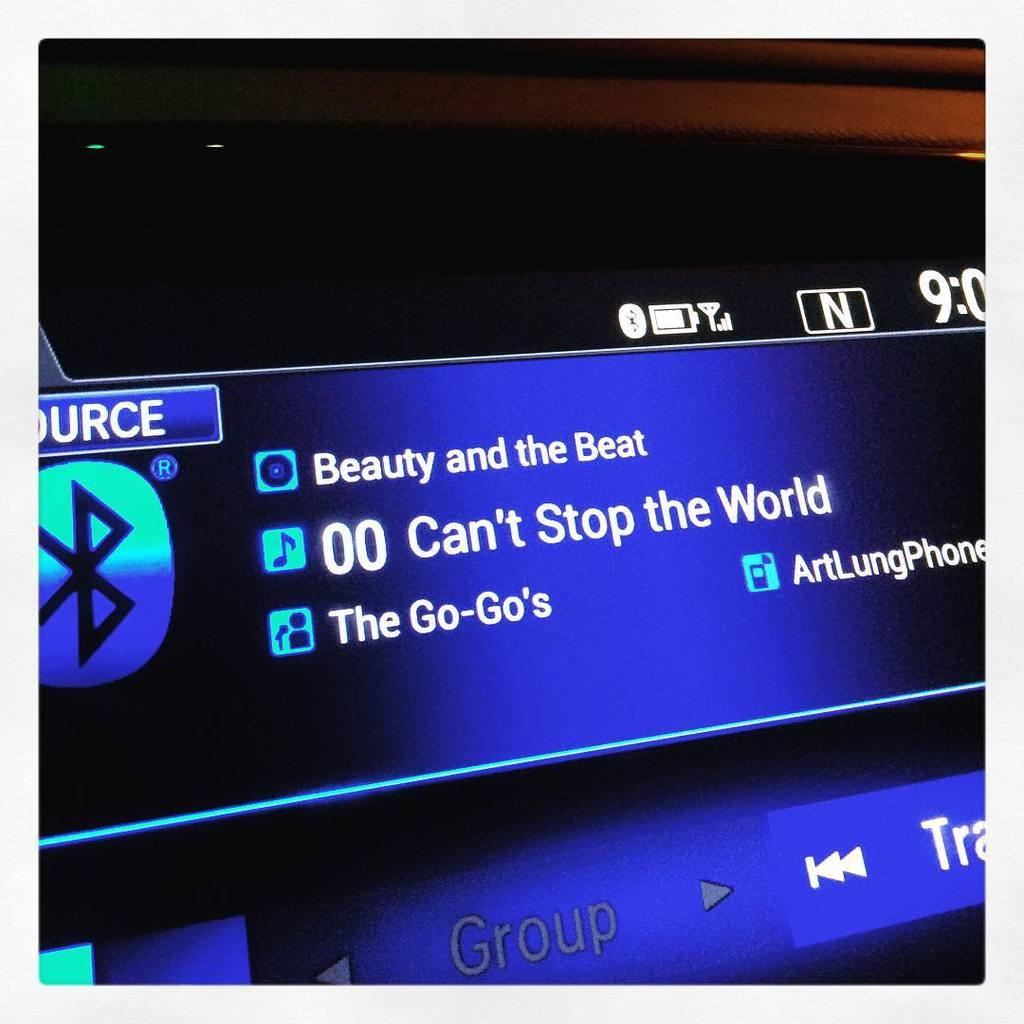<image>
Render a clear and concise summary of the photo. A car radio digital display playing beauty and the beat. 